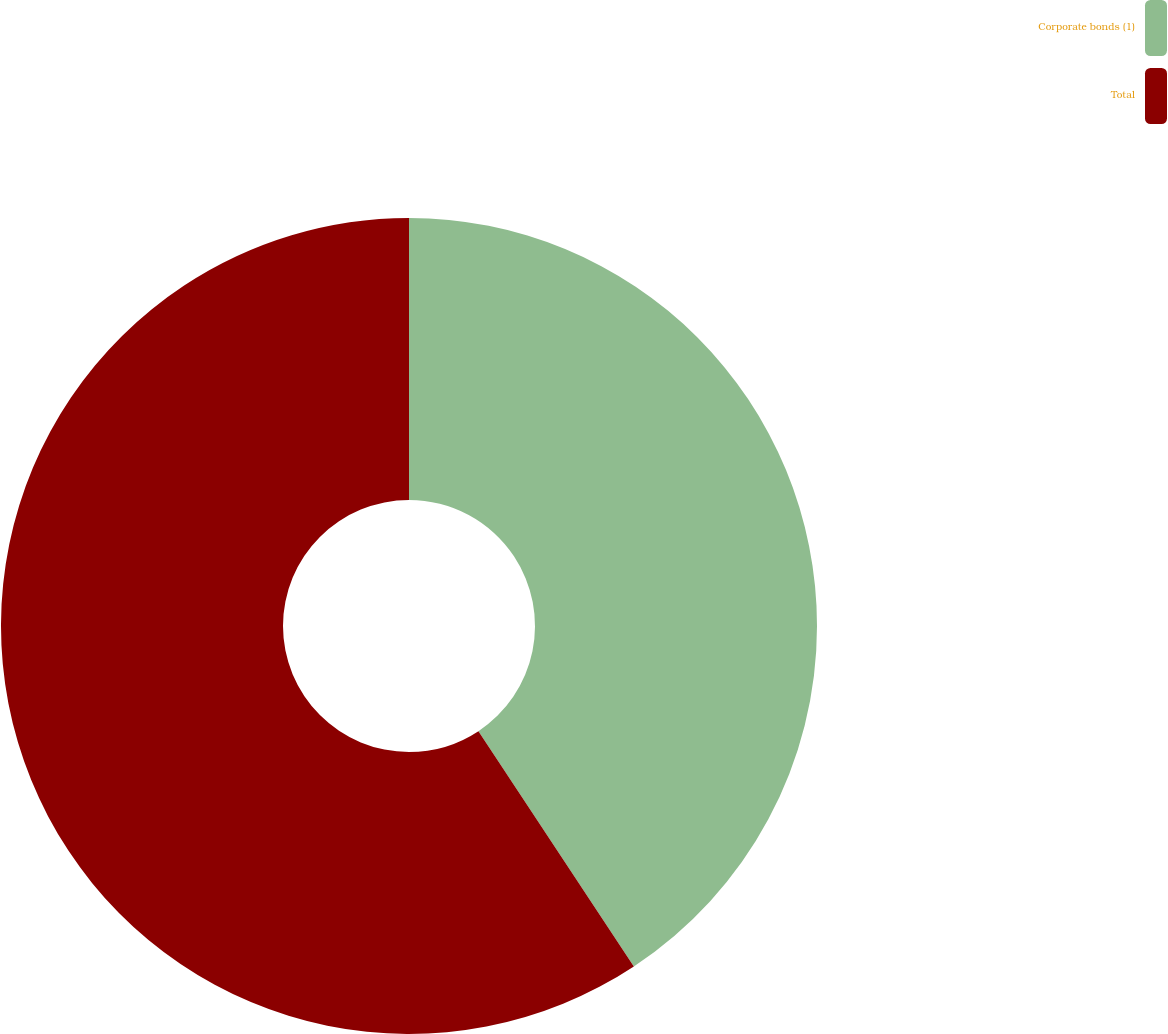<chart> <loc_0><loc_0><loc_500><loc_500><pie_chart><fcel>Corporate bonds (1)<fcel>Total<nl><fcel>40.71%<fcel>59.29%<nl></chart> 